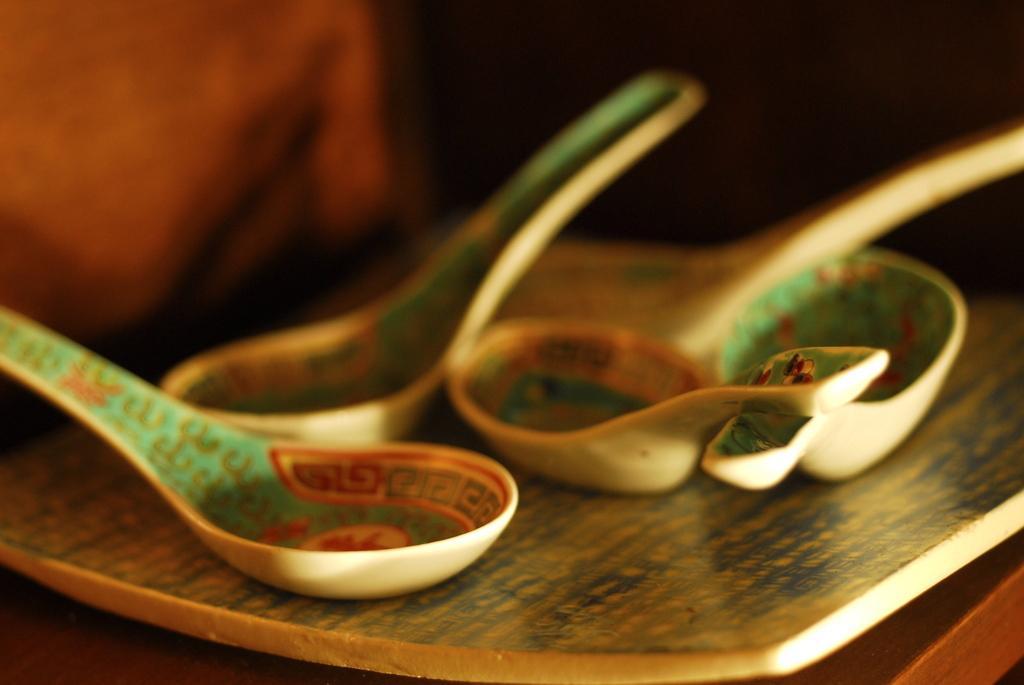Please provide a concise description of this image. This image consists of a plate and spoons. They all are kept on a table. This image looks like it is clicked inside the room. 